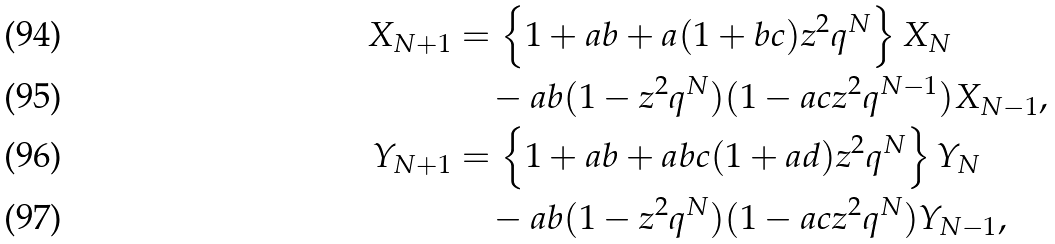<formula> <loc_0><loc_0><loc_500><loc_500>X _ { N + 1 } & = \left \{ 1 + a b + a ( 1 + b c ) z ^ { 2 } q ^ { N } \right \} X _ { N } \\ & \quad - a b ( 1 - z ^ { 2 } q ^ { N } ) ( 1 - a c z ^ { 2 } q ^ { N - 1 } ) X _ { N - 1 } , \\ Y _ { N + 1 } & = \left \{ 1 + a b + a b c ( 1 + a d ) z ^ { 2 } q ^ { N } \right \} Y _ { N } \\ & \quad - a b ( 1 - z ^ { 2 } q ^ { N } ) ( 1 - a c z ^ { 2 } q ^ { N } ) Y _ { N - 1 } ,</formula> 